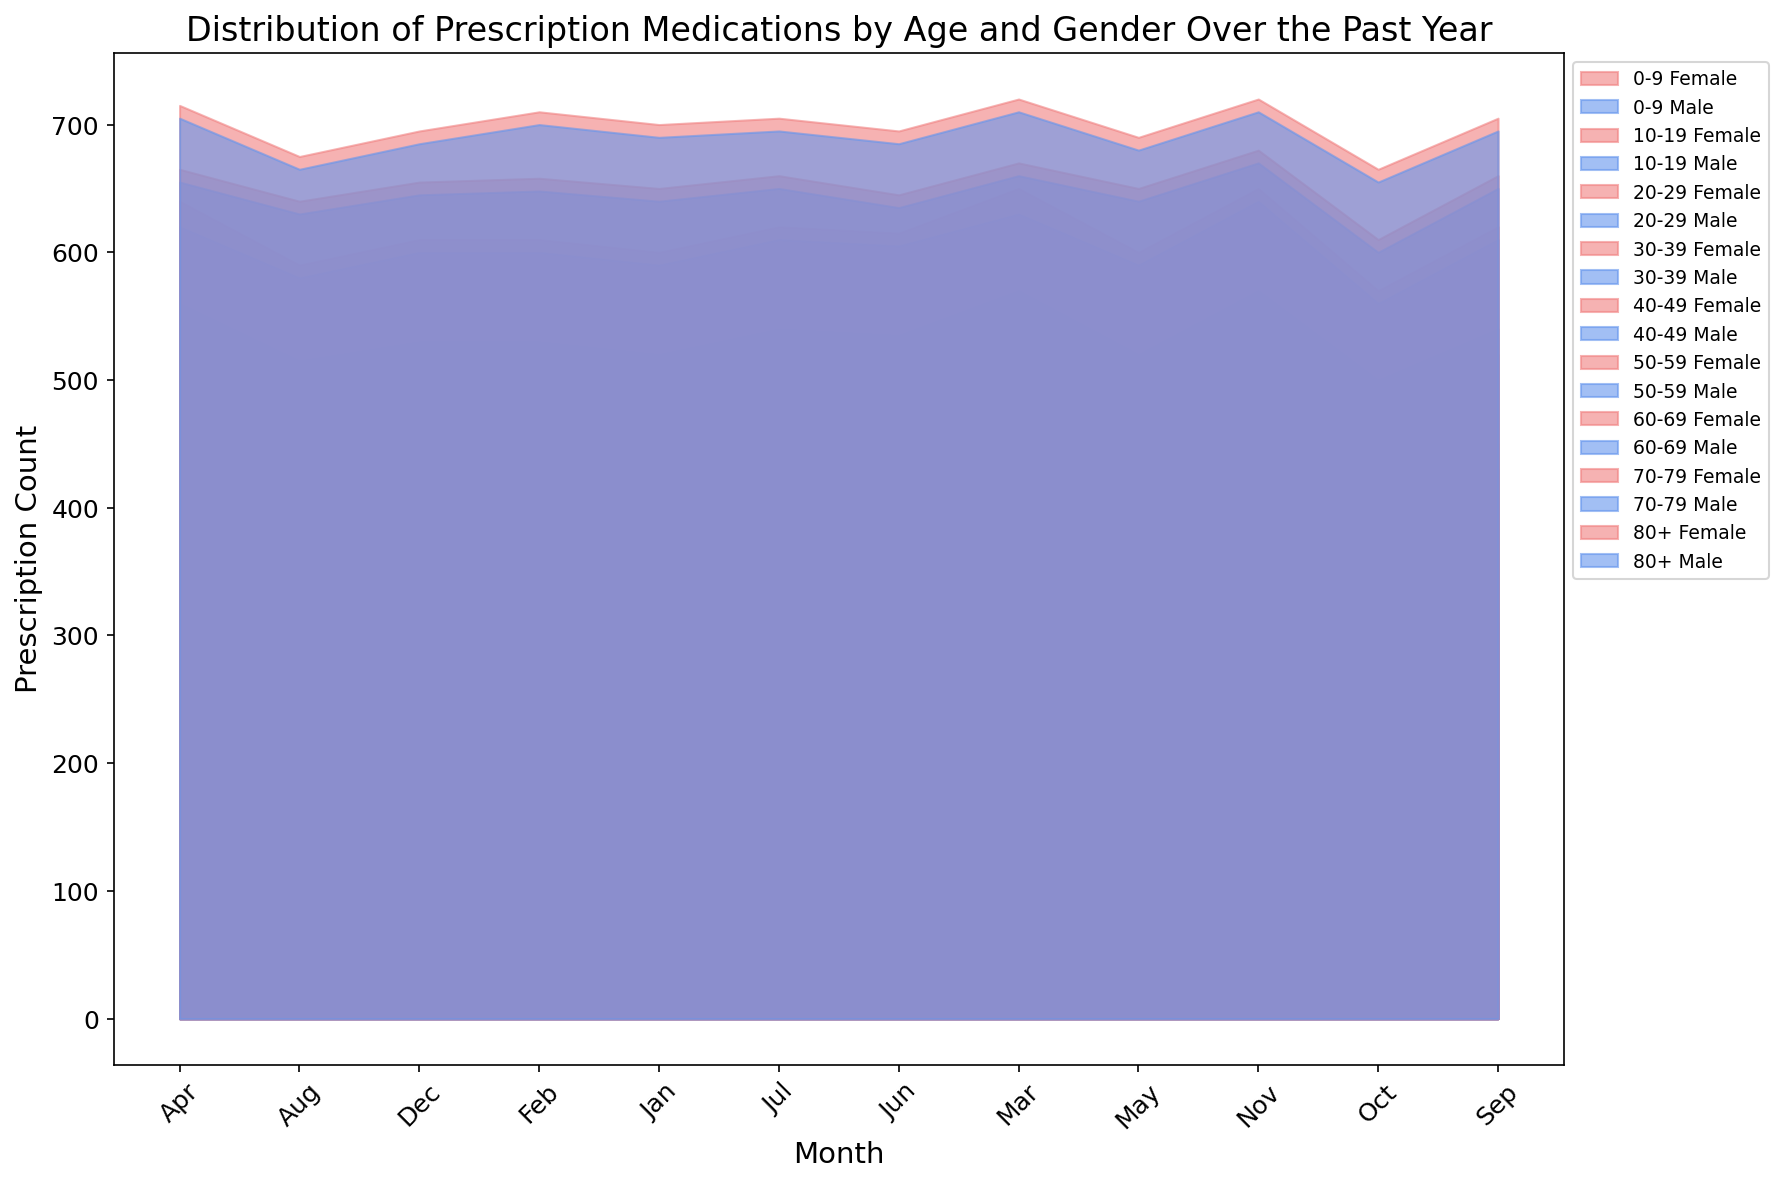How do the prescription counts compare between males and females in the 40-49 age group in January? In January, the chart shows that the area for males in the 40-49 age group is slightly smaller compared to females. This indicates prescription counts are slightly higher for females than for males.
Answer: Females have more prescriptions Which month has the highest total prescription count for the 60-69 age group? By visually inspecting the area heights, the 60-69 age group's highest prescription counts appear to be in March for both males and females, as the areas are largest in this month for this age group.
Answer: March Compare the prescription counts for males and females in the 10-19 age group in April. In April, the area chart shows the prescription count areas for both males and females in the 10-19 age group. The areas for females are slightly smaller than for males, indicating males have more prescriptions in this age group for April.
Answer: Males have more prescriptions What is the difference in prescription counts between males and females in the 80+ age group in November? In November, the chart shows the area for males in the 80+ age group, and the area for females in the same age group. The areas suggest that both genders have almost equal counts with males slightly less.
Answer: Females have slightly more prescriptions Which age group has the most consistent prescription counts throughout the year for both genders? Visually examining the consistency of the areas for each age group throughout the year, the 30-39 age group appears to have the most stable areas with fewer fluctuations for both genders.
Answer: 30-39 age group How does the trend in prescription counts for the 20-29 age group differ between genders over the year? The 20-29 age group shows that male and female prescription counts are similar initially but diverge slightly in some months, with females slightly higher in a few months such as March and December, while males are higher in others like June.
Answer: Females slightly higher in March and December; males higher in June Compare the peak prescription counts month for males and females in the 50-59 age group. The chart shows that the peak for males and females in the 50-59 age group occurs in March for males and in July for females. The areas for this age group peak in these months indicating the highest prescription counts.
Answer: March for males, July for females What is the sum of prescription counts for females aged 70-79 in July and August? From the chart, the prescription counts for females aged 70-79 in July and August are visible. Summing the area heights for these months, July has 660 and August has 640 prescriptions. Summing these gives 660 + 640 = 1300.
Answer: 1300 How does the prescription count trend change from June to July for the 0-9 age group? Observing the area charts, the prescription counts for the 0-9 age group increase slightly from June to July for both males and females as represented by the slightly larger areas in July compared to June.
Answer: Increase Which gender has higher prescription counts in the 30-39 age group for the entire year? Throughout the year, the area heights for the 30-39 age group are consistently higher for females compared to males except for a few months where they are roughly equal. This indicates females have higher prescription counts overall in this age group.
Answer: Females 